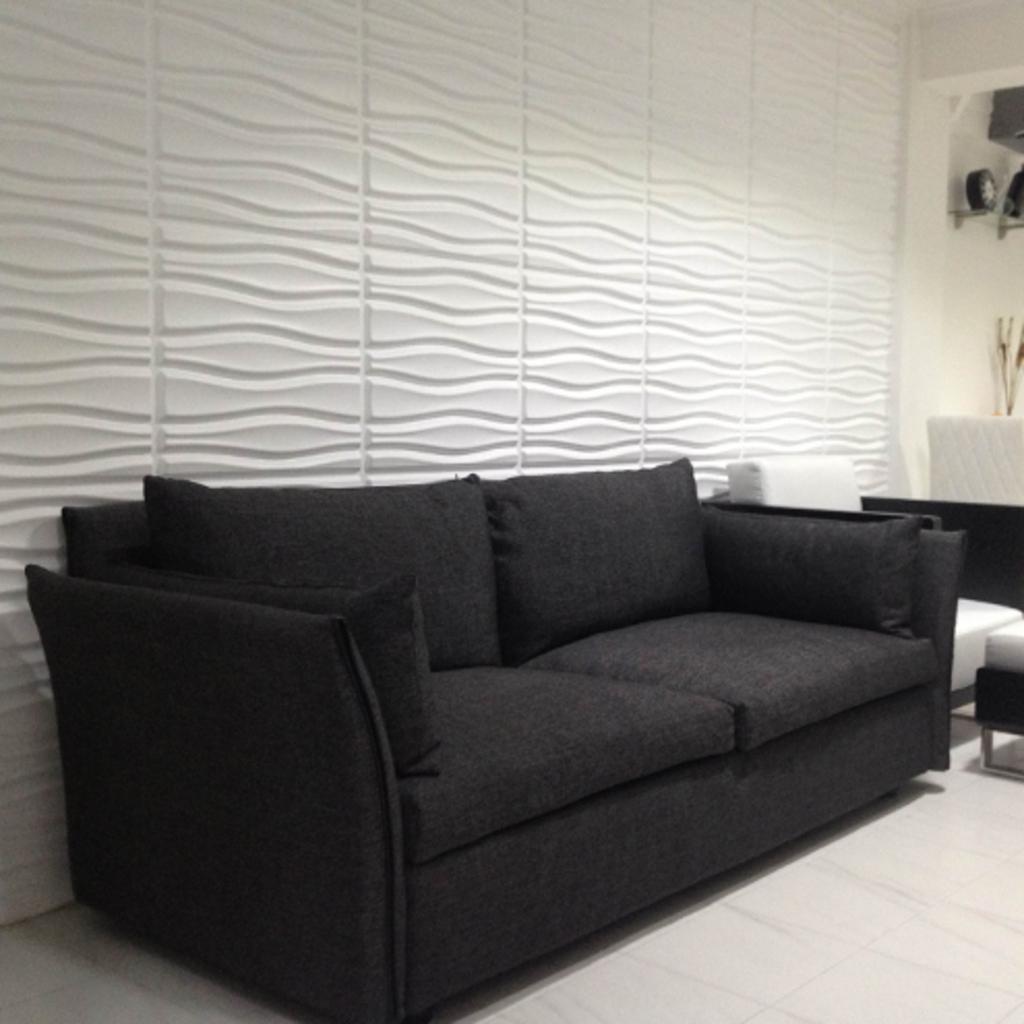In one or two sentences, can you explain what this image depicts? This is a picture of inside view of an house and there is a black color sofa set on the floor and there is a white color wall with design and there is a clock attached to the stand kept on the wall. 